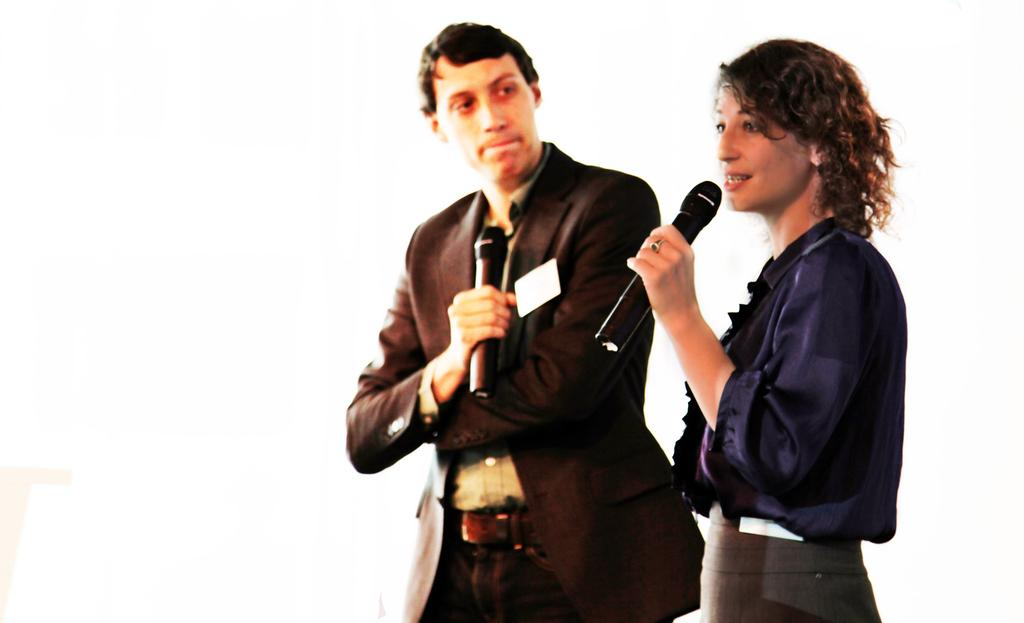What is the woman in the image holding? The woman is holding a mic in her hand. What is the woman doing in the image? The woman is talking. Who else is present in the image? There is a man in the image. What is the man holding in the image? The man is holding a mic. What is the man doing in the image? The man is looking at the woman. What is the man wearing in the image? The man is wearing a blazer. What type of button can be seen on the woman's shirt in the image? There is no button visible on the woman's shirt in the image. How does the man show respect to the woman in the image? The image does not depict any specific actions that indicate the man is showing respect to the woman. 